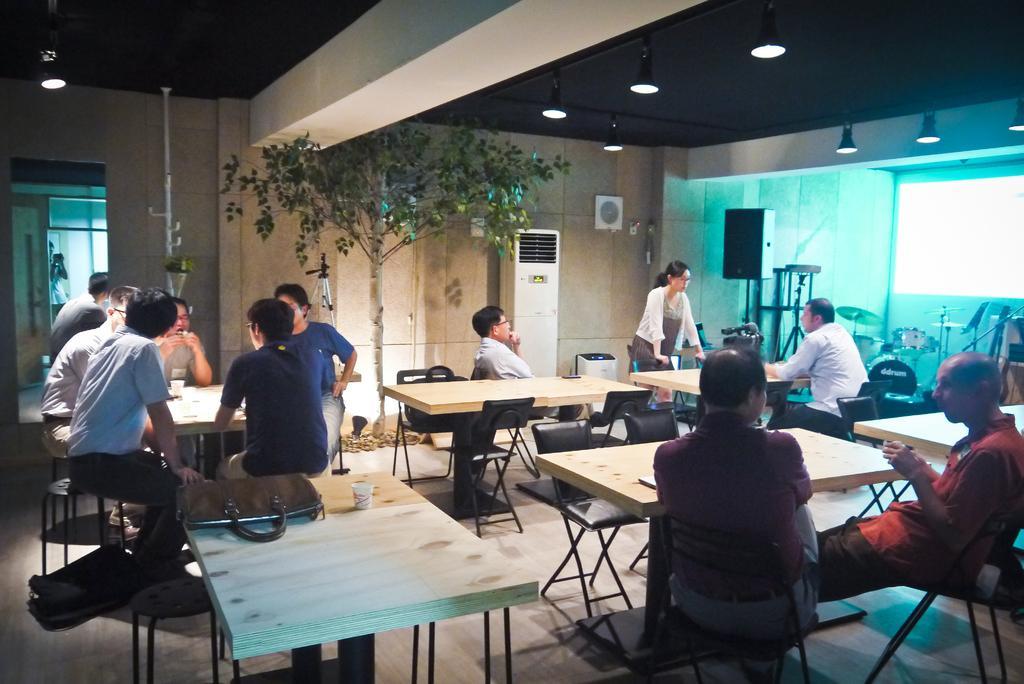Please provide a concise description of this image. in this image the many people they are sitting the chair and one woman she is standing on the floor the room has tables,chairs,bags and cups and the back ground is like white. 